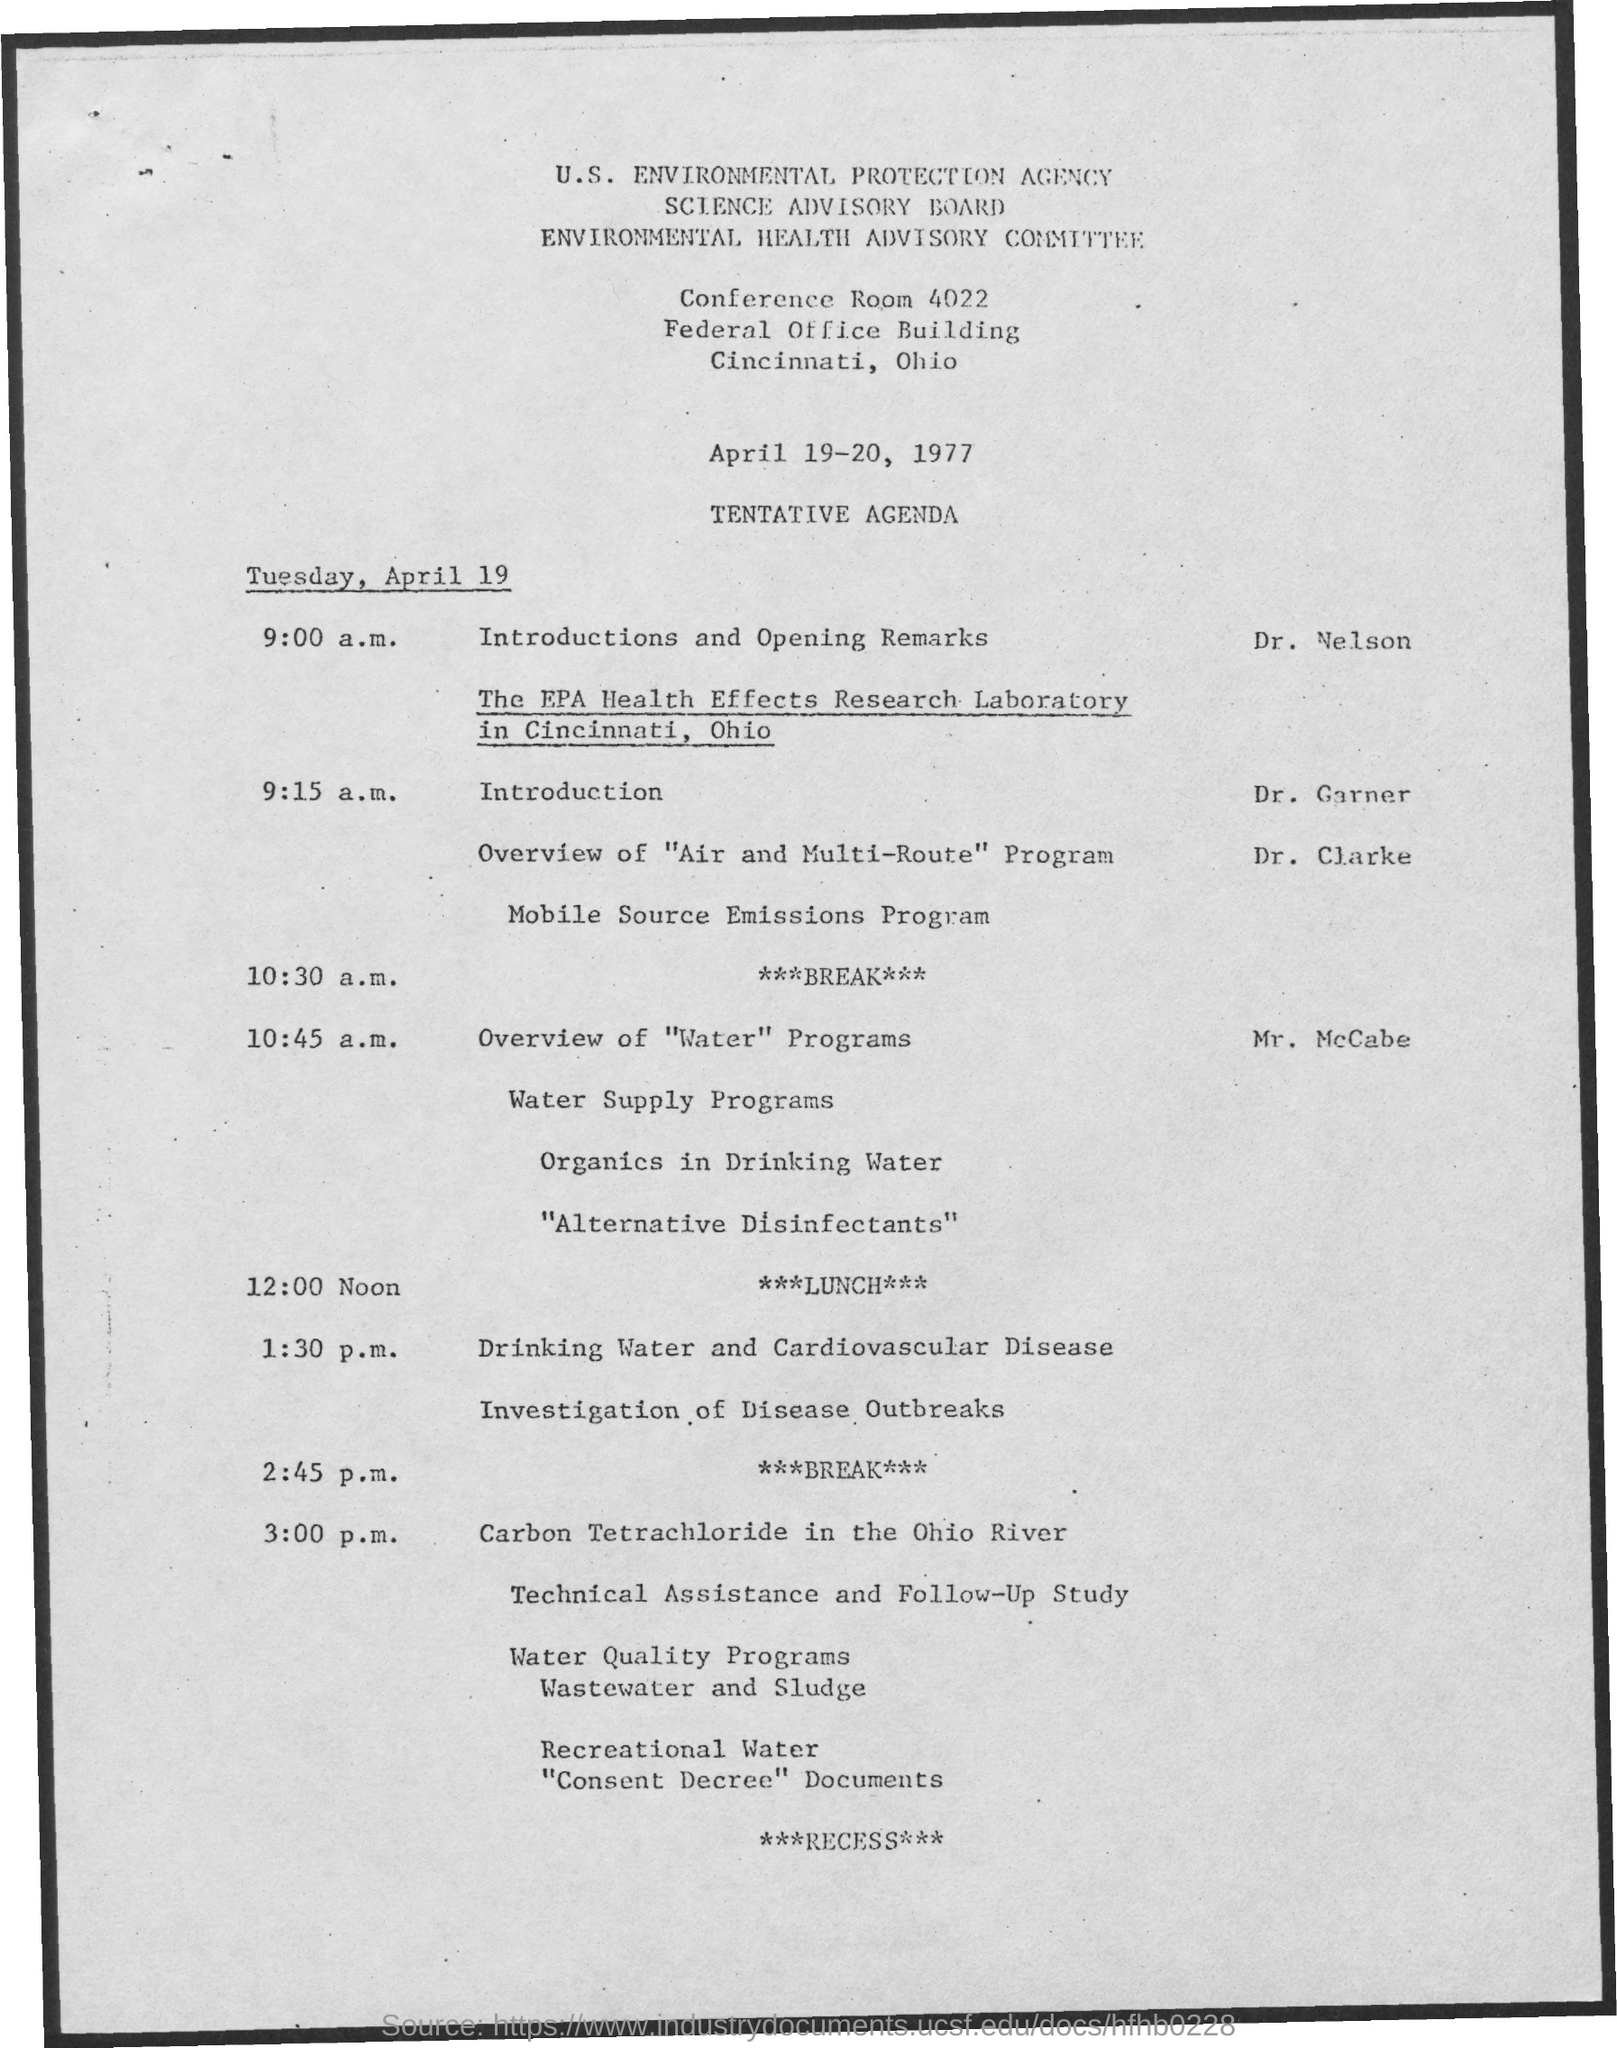Give some essential details in this illustration. The schedule at 12:00 noon on April 19, 2023, is 12:00 noon and it is referred to as "LUNCH. The conference room number mentioned is 4022. The Science Advisory Board is a named board mentioned. The dates mentioned are April 19-20, 1977. The U.S. Environmental Protection Agency (EPA) is the name of the agency mentioned. 